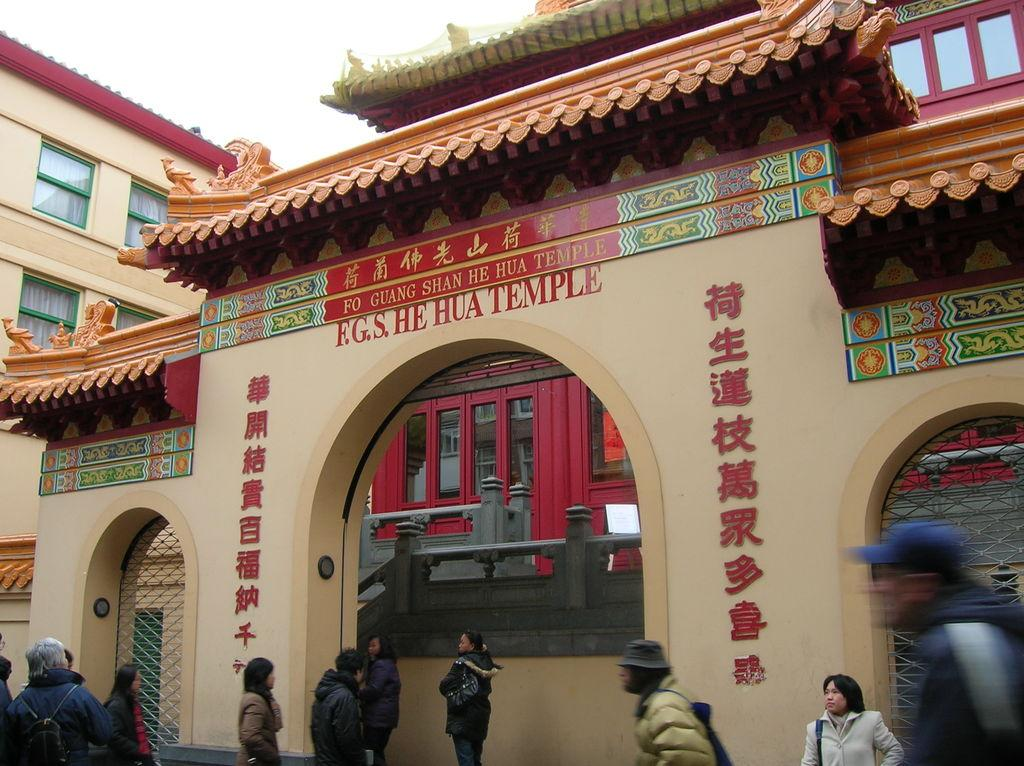Who or what can be seen in the image? There are people in the image. What type of structures are visible in the image? There are buildings with windows in the image. What can be observed on the glass surfaces in the image? There are reflections on the glass in the image. What part of the natural environment is visible in the image? The sky is visible in the image. What type of pest can be seen crawling on the buildings in the image? There is no pest visible in the image; the buildings have windows and reflections, but no pests are mentioned in the facts. 